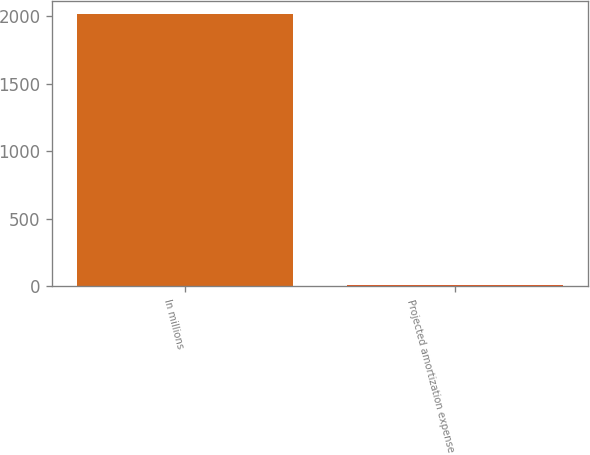Convert chart to OTSL. <chart><loc_0><loc_0><loc_500><loc_500><bar_chart><fcel>In millions<fcel>Projected amortization expense<nl><fcel>2014<fcel>13<nl></chart> 